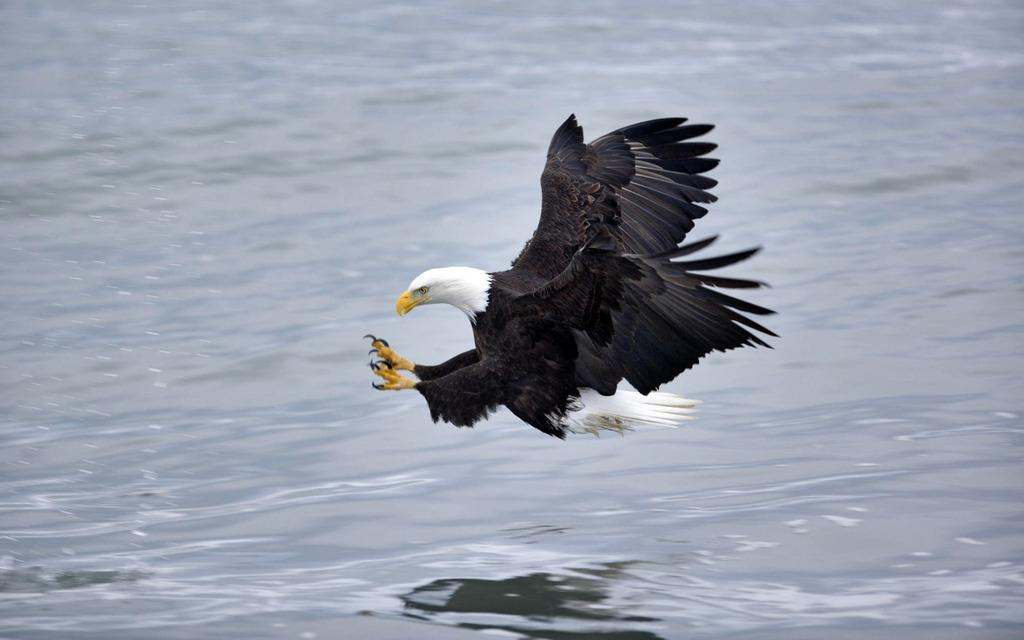What animal can be seen in the image? There is an eagle in the image. What is the eagle doing in the image? The eagle is flying in the air. What can be seen in the background of the image? There is water visible in the background of the image. What type of jeans is the eagle wearing in the image? The eagle is a bird and does not wear clothing, so it is not wearing jeans in the image. 